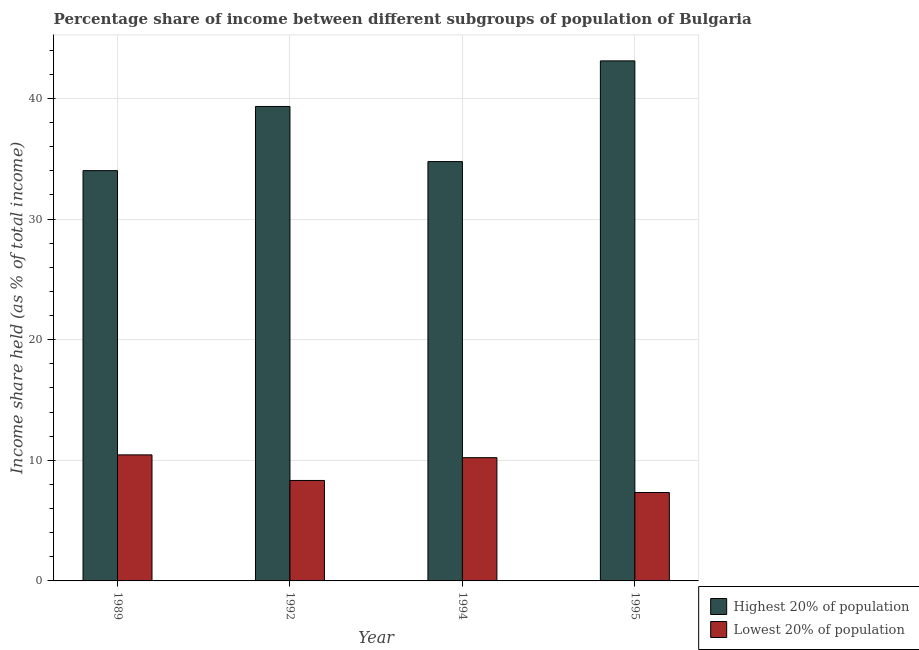Are the number of bars on each tick of the X-axis equal?
Your answer should be very brief. Yes. In how many cases, is the number of bars for a given year not equal to the number of legend labels?
Your answer should be very brief. 0. What is the income share held by highest 20% of the population in 1989?
Offer a terse response. 34.02. Across all years, what is the maximum income share held by highest 20% of the population?
Ensure brevity in your answer.  43.12. Across all years, what is the minimum income share held by highest 20% of the population?
Offer a very short reply. 34.02. In which year was the income share held by lowest 20% of the population maximum?
Give a very brief answer. 1989. In which year was the income share held by lowest 20% of the population minimum?
Your response must be concise. 1995. What is the total income share held by highest 20% of the population in the graph?
Your answer should be compact. 151.25. What is the difference between the income share held by lowest 20% of the population in 1992 and that in 1994?
Your answer should be very brief. -1.89. What is the difference between the income share held by highest 20% of the population in 1995 and the income share held by lowest 20% of the population in 1992?
Offer a terse response. 3.78. What is the average income share held by highest 20% of the population per year?
Your answer should be compact. 37.81. What is the ratio of the income share held by lowest 20% of the population in 1989 to that in 1992?
Keep it short and to the point. 1.25. Is the income share held by highest 20% of the population in 1989 less than that in 1992?
Offer a very short reply. Yes. What is the difference between the highest and the second highest income share held by highest 20% of the population?
Give a very brief answer. 3.78. What is the difference between the highest and the lowest income share held by highest 20% of the population?
Provide a succinct answer. 9.1. Is the sum of the income share held by highest 20% of the population in 1989 and 1994 greater than the maximum income share held by lowest 20% of the population across all years?
Your answer should be compact. Yes. What does the 2nd bar from the left in 1994 represents?
Make the answer very short. Lowest 20% of population. What does the 1st bar from the right in 1989 represents?
Your answer should be very brief. Lowest 20% of population. Are all the bars in the graph horizontal?
Your answer should be compact. No. Does the graph contain any zero values?
Provide a short and direct response. No. Does the graph contain grids?
Your response must be concise. Yes. What is the title of the graph?
Offer a terse response. Percentage share of income between different subgroups of population of Bulgaria. Does "Number of arrivals" appear as one of the legend labels in the graph?
Provide a succinct answer. No. What is the label or title of the X-axis?
Make the answer very short. Year. What is the label or title of the Y-axis?
Keep it short and to the point. Income share held (as % of total income). What is the Income share held (as % of total income) of Highest 20% of population in 1989?
Your answer should be very brief. 34.02. What is the Income share held (as % of total income) in Lowest 20% of population in 1989?
Offer a terse response. 10.45. What is the Income share held (as % of total income) in Highest 20% of population in 1992?
Your answer should be compact. 39.34. What is the Income share held (as % of total income) of Lowest 20% of population in 1992?
Your answer should be very brief. 8.33. What is the Income share held (as % of total income) in Highest 20% of population in 1994?
Offer a terse response. 34.77. What is the Income share held (as % of total income) in Lowest 20% of population in 1994?
Make the answer very short. 10.22. What is the Income share held (as % of total income) of Highest 20% of population in 1995?
Provide a short and direct response. 43.12. What is the Income share held (as % of total income) of Lowest 20% of population in 1995?
Provide a succinct answer. 7.33. Across all years, what is the maximum Income share held (as % of total income) in Highest 20% of population?
Offer a terse response. 43.12. Across all years, what is the maximum Income share held (as % of total income) of Lowest 20% of population?
Make the answer very short. 10.45. Across all years, what is the minimum Income share held (as % of total income) in Highest 20% of population?
Offer a very short reply. 34.02. Across all years, what is the minimum Income share held (as % of total income) of Lowest 20% of population?
Offer a very short reply. 7.33. What is the total Income share held (as % of total income) of Highest 20% of population in the graph?
Your response must be concise. 151.25. What is the total Income share held (as % of total income) in Lowest 20% of population in the graph?
Your response must be concise. 36.33. What is the difference between the Income share held (as % of total income) in Highest 20% of population in 1989 and that in 1992?
Give a very brief answer. -5.32. What is the difference between the Income share held (as % of total income) of Lowest 20% of population in 1989 and that in 1992?
Your answer should be compact. 2.12. What is the difference between the Income share held (as % of total income) of Highest 20% of population in 1989 and that in 1994?
Make the answer very short. -0.75. What is the difference between the Income share held (as % of total income) of Lowest 20% of population in 1989 and that in 1994?
Offer a very short reply. 0.23. What is the difference between the Income share held (as % of total income) in Highest 20% of population in 1989 and that in 1995?
Your response must be concise. -9.1. What is the difference between the Income share held (as % of total income) of Lowest 20% of population in 1989 and that in 1995?
Provide a succinct answer. 3.12. What is the difference between the Income share held (as % of total income) of Highest 20% of population in 1992 and that in 1994?
Keep it short and to the point. 4.57. What is the difference between the Income share held (as % of total income) of Lowest 20% of population in 1992 and that in 1994?
Make the answer very short. -1.89. What is the difference between the Income share held (as % of total income) of Highest 20% of population in 1992 and that in 1995?
Provide a short and direct response. -3.78. What is the difference between the Income share held (as % of total income) of Lowest 20% of population in 1992 and that in 1995?
Provide a succinct answer. 1. What is the difference between the Income share held (as % of total income) of Highest 20% of population in 1994 and that in 1995?
Keep it short and to the point. -8.35. What is the difference between the Income share held (as % of total income) in Lowest 20% of population in 1994 and that in 1995?
Give a very brief answer. 2.89. What is the difference between the Income share held (as % of total income) of Highest 20% of population in 1989 and the Income share held (as % of total income) of Lowest 20% of population in 1992?
Keep it short and to the point. 25.69. What is the difference between the Income share held (as % of total income) in Highest 20% of population in 1989 and the Income share held (as % of total income) in Lowest 20% of population in 1994?
Offer a very short reply. 23.8. What is the difference between the Income share held (as % of total income) in Highest 20% of population in 1989 and the Income share held (as % of total income) in Lowest 20% of population in 1995?
Ensure brevity in your answer.  26.69. What is the difference between the Income share held (as % of total income) in Highest 20% of population in 1992 and the Income share held (as % of total income) in Lowest 20% of population in 1994?
Ensure brevity in your answer.  29.12. What is the difference between the Income share held (as % of total income) in Highest 20% of population in 1992 and the Income share held (as % of total income) in Lowest 20% of population in 1995?
Offer a terse response. 32.01. What is the difference between the Income share held (as % of total income) in Highest 20% of population in 1994 and the Income share held (as % of total income) in Lowest 20% of population in 1995?
Your response must be concise. 27.44. What is the average Income share held (as % of total income) in Highest 20% of population per year?
Keep it short and to the point. 37.81. What is the average Income share held (as % of total income) of Lowest 20% of population per year?
Give a very brief answer. 9.08. In the year 1989, what is the difference between the Income share held (as % of total income) of Highest 20% of population and Income share held (as % of total income) of Lowest 20% of population?
Provide a short and direct response. 23.57. In the year 1992, what is the difference between the Income share held (as % of total income) in Highest 20% of population and Income share held (as % of total income) in Lowest 20% of population?
Ensure brevity in your answer.  31.01. In the year 1994, what is the difference between the Income share held (as % of total income) in Highest 20% of population and Income share held (as % of total income) in Lowest 20% of population?
Keep it short and to the point. 24.55. In the year 1995, what is the difference between the Income share held (as % of total income) of Highest 20% of population and Income share held (as % of total income) of Lowest 20% of population?
Your answer should be compact. 35.79. What is the ratio of the Income share held (as % of total income) in Highest 20% of population in 1989 to that in 1992?
Keep it short and to the point. 0.86. What is the ratio of the Income share held (as % of total income) in Lowest 20% of population in 1989 to that in 1992?
Make the answer very short. 1.25. What is the ratio of the Income share held (as % of total income) in Highest 20% of population in 1989 to that in 1994?
Your response must be concise. 0.98. What is the ratio of the Income share held (as % of total income) in Lowest 20% of population in 1989 to that in 1994?
Ensure brevity in your answer.  1.02. What is the ratio of the Income share held (as % of total income) in Highest 20% of population in 1989 to that in 1995?
Give a very brief answer. 0.79. What is the ratio of the Income share held (as % of total income) in Lowest 20% of population in 1989 to that in 1995?
Make the answer very short. 1.43. What is the ratio of the Income share held (as % of total income) in Highest 20% of population in 1992 to that in 1994?
Your response must be concise. 1.13. What is the ratio of the Income share held (as % of total income) of Lowest 20% of population in 1992 to that in 1994?
Offer a very short reply. 0.82. What is the ratio of the Income share held (as % of total income) in Highest 20% of population in 1992 to that in 1995?
Give a very brief answer. 0.91. What is the ratio of the Income share held (as % of total income) in Lowest 20% of population in 1992 to that in 1995?
Your answer should be very brief. 1.14. What is the ratio of the Income share held (as % of total income) of Highest 20% of population in 1994 to that in 1995?
Ensure brevity in your answer.  0.81. What is the ratio of the Income share held (as % of total income) of Lowest 20% of population in 1994 to that in 1995?
Offer a terse response. 1.39. What is the difference between the highest and the second highest Income share held (as % of total income) of Highest 20% of population?
Make the answer very short. 3.78. What is the difference between the highest and the second highest Income share held (as % of total income) of Lowest 20% of population?
Your answer should be very brief. 0.23. What is the difference between the highest and the lowest Income share held (as % of total income) in Highest 20% of population?
Offer a terse response. 9.1. What is the difference between the highest and the lowest Income share held (as % of total income) of Lowest 20% of population?
Provide a short and direct response. 3.12. 